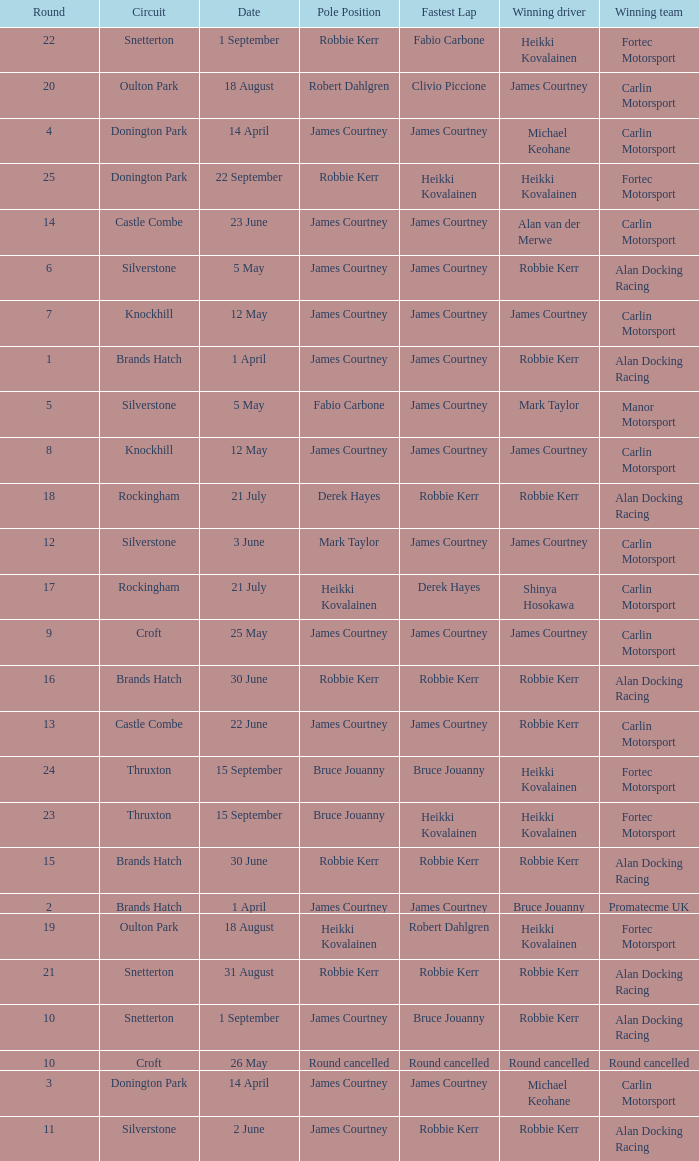What is every pole position for the Castle Combe circuit and Robbie Kerr is the winning driver? James Courtney. 